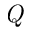Convert formula to latex. <formula><loc_0><loc_0><loc_500><loc_500>Q</formula> 